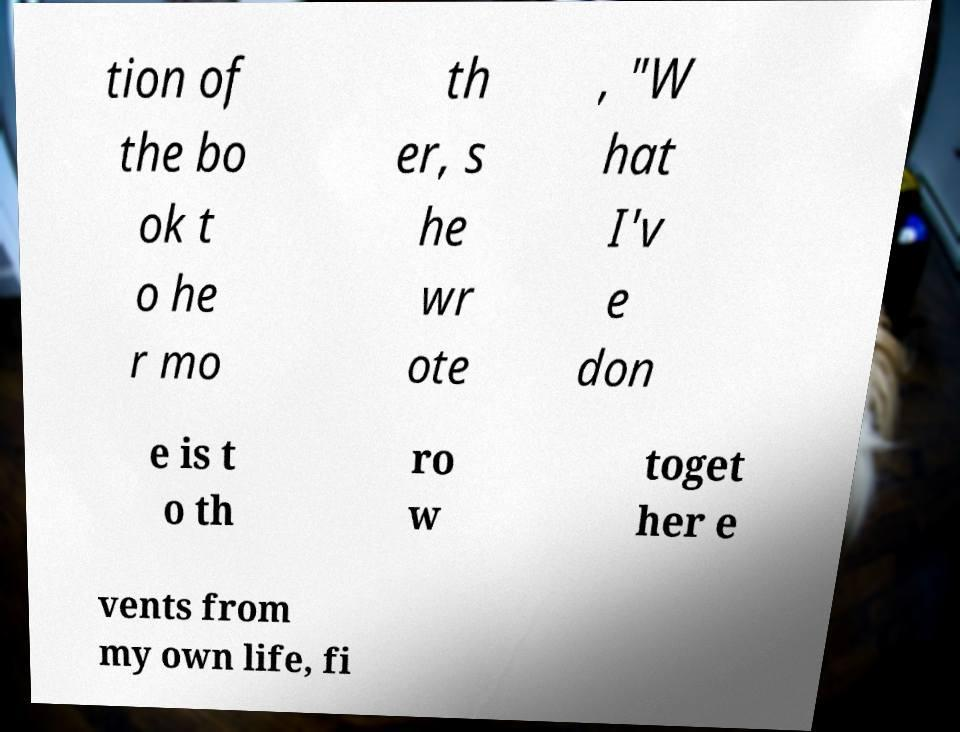Can you read and provide the text displayed in the image?This photo seems to have some interesting text. Can you extract and type it out for me? tion of the bo ok t o he r mo th er, s he wr ote , "W hat I'v e don e is t o th ro w toget her e vents from my own life, fi 